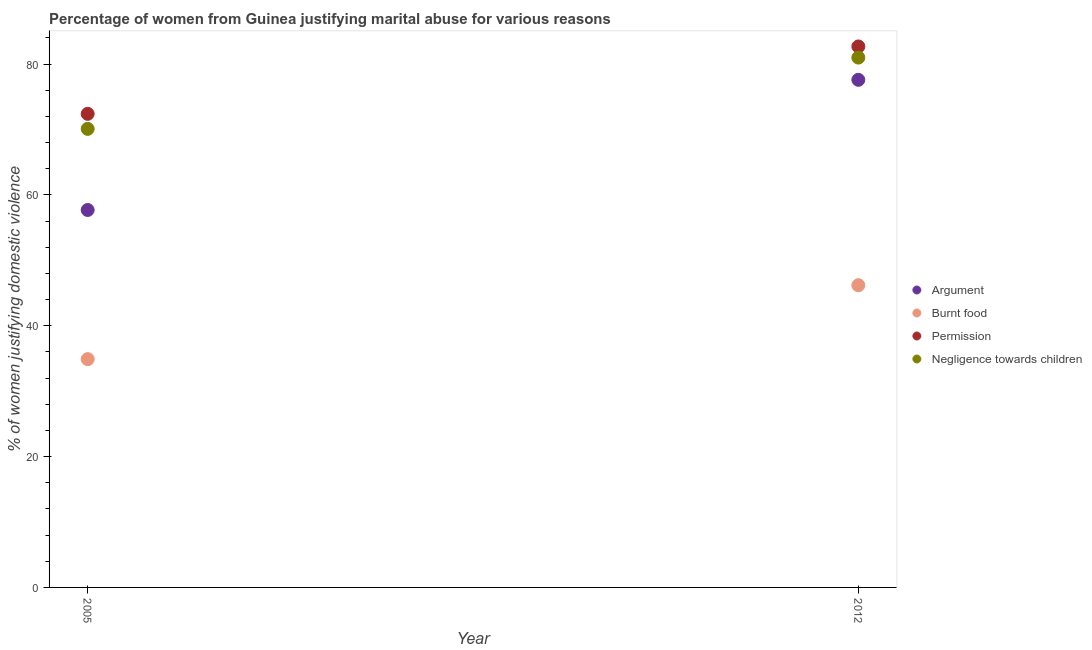How many different coloured dotlines are there?
Ensure brevity in your answer.  4. What is the percentage of women justifying abuse for showing negligence towards children in 2012?
Offer a terse response. 81. Across all years, what is the maximum percentage of women justifying abuse for going without permission?
Your answer should be compact. 82.7. Across all years, what is the minimum percentage of women justifying abuse for showing negligence towards children?
Keep it short and to the point. 70.1. What is the total percentage of women justifying abuse for showing negligence towards children in the graph?
Offer a terse response. 151.1. What is the difference between the percentage of women justifying abuse for showing negligence towards children in 2005 and that in 2012?
Keep it short and to the point. -10.9. What is the difference between the percentage of women justifying abuse for showing negligence towards children in 2012 and the percentage of women justifying abuse in the case of an argument in 2005?
Give a very brief answer. 23.3. What is the average percentage of women justifying abuse for showing negligence towards children per year?
Make the answer very short. 75.55. In the year 2012, what is the difference between the percentage of women justifying abuse for going without permission and percentage of women justifying abuse for burning food?
Provide a succinct answer. 36.5. In how many years, is the percentage of women justifying abuse in the case of an argument greater than 64 %?
Offer a terse response. 1. What is the ratio of the percentage of women justifying abuse for showing negligence towards children in 2005 to that in 2012?
Make the answer very short. 0.87. Is it the case that in every year, the sum of the percentage of women justifying abuse in the case of an argument and percentage of women justifying abuse for burning food is greater than the sum of percentage of women justifying abuse for going without permission and percentage of women justifying abuse for showing negligence towards children?
Keep it short and to the point. No. Is it the case that in every year, the sum of the percentage of women justifying abuse in the case of an argument and percentage of women justifying abuse for burning food is greater than the percentage of women justifying abuse for going without permission?
Your answer should be very brief. Yes. Does the percentage of women justifying abuse for burning food monotonically increase over the years?
Keep it short and to the point. Yes. Does the graph contain grids?
Offer a terse response. No. Where does the legend appear in the graph?
Ensure brevity in your answer.  Center right. How many legend labels are there?
Make the answer very short. 4. How are the legend labels stacked?
Make the answer very short. Vertical. What is the title of the graph?
Make the answer very short. Percentage of women from Guinea justifying marital abuse for various reasons. What is the label or title of the Y-axis?
Provide a short and direct response. % of women justifying domestic violence. What is the % of women justifying domestic violence of Argument in 2005?
Keep it short and to the point. 57.7. What is the % of women justifying domestic violence in Burnt food in 2005?
Offer a terse response. 34.9. What is the % of women justifying domestic violence of Permission in 2005?
Your answer should be compact. 72.4. What is the % of women justifying domestic violence in Negligence towards children in 2005?
Keep it short and to the point. 70.1. What is the % of women justifying domestic violence of Argument in 2012?
Your answer should be very brief. 77.6. What is the % of women justifying domestic violence in Burnt food in 2012?
Offer a very short reply. 46.2. What is the % of women justifying domestic violence in Permission in 2012?
Ensure brevity in your answer.  82.7. What is the % of women justifying domestic violence of Negligence towards children in 2012?
Your answer should be compact. 81. Across all years, what is the maximum % of women justifying domestic violence of Argument?
Provide a succinct answer. 77.6. Across all years, what is the maximum % of women justifying domestic violence of Burnt food?
Provide a short and direct response. 46.2. Across all years, what is the maximum % of women justifying domestic violence of Permission?
Your response must be concise. 82.7. Across all years, what is the minimum % of women justifying domestic violence of Argument?
Provide a short and direct response. 57.7. Across all years, what is the minimum % of women justifying domestic violence of Burnt food?
Provide a succinct answer. 34.9. Across all years, what is the minimum % of women justifying domestic violence in Permission?
Make the answer very short. 72.4. Across all years, what is the minimum % of women justifying domestic violence of Negligence towards children?
Offer a very short reply. 70.1. What is the total % of women justifying domestic violence of Argument in the graph?
Give a very brief answer. 135.3. What is the total % of women justifying domestic violence of Burnt food in the graph?
Your response must be concise. 81.1. What is the total % of women justifying domestic violence of Permission in the graph?
Provide a succinct answer. 155.1. What is the total % of women justifying domestic violence in Negligence towards children in the graph?
Provide a succinct answer. 151.1. What is the difference between the % of women justifying domestic violence of Argument in 2005 and that in 2012?
Provide a succinct answer. -19.9. What is the difference between the % of women justifying domestic violence of Burnt food in 2005 and that in 2012?
Offer a terse response. -11.3. What is the difference between the % of women justifying domestic violence of Permission in 2005 and that in 2012?
Ensure brevity in your answer.  -10.3. What is the difference between the % of women justifying domestic violence of Negligence towards children in 2005 and that in 2012?
Make the answer very short. -10.9. What is the difference between the % of women justifying domestic violence in Argument in 2005 and the % of women justifying domestic violence in Negligence towards children in 2012?
Your answer should be compact. -23.3. What is the difference between the % of women justifying domestic violence in Burnt food in 2005 and the % of women justifying domestic violence in Permission in 2012?
Provide a short and direct response. -47.8. What is the difference between the % of women justifying domestic violence in Burnt food in 2005 and the % of women justifying domestic violence in Negligence towards children in 2012?
Provide a succinct answer. -46.1. What is the average % of women justifying domestic violence in Argument per year?
Give a very brief answer. 67.65. What is the average % of women justifying domestic violence of Burnt food per year?
Offer a terse response. 40.55. What is the average % of women justifying domestic violence in Permission per year?
Offer a very short reply. 77.55. What is the average % of women justifying domestic violence of Negligence towards children per year?
Offer a very short reply. 75.55. In the year 2005, what is the difference between the % of women justifying domestic violence in Argument and % of women justifying domestic violence in Burnt food?
Keep it short and to the point. 22.8. In the year 2005, what is the difference between the % of women justifying domestic violence of Argument and % of women justifying domestic violence of Permission?
Offer a terse response. -14.7. In the year 2005, what is the difference between the % of women justifying domestic violence in Argument and % of women justifying domestic violence in Negligence towards children?
Make the answer very short. -12.4. In the year 2005, what is the difference between the % of women justifying domestic violence in Burnt food and % of women justifying domestic violence in Permission?
Your response must be concise. -37.5. In the year 2005, what is the difference between the % of women justifying domestic violence in Burnt food and % of women justifying domestic violence in Negligence towards children?
Offer a very short reply. -35.2. In the year 2005, what is the difference between the % of women justifying domestic violence in Permission and % of women justifying domestic violence in Negligence towards children?
Offer a terse response. 2.3. In the year 2012, what is the difference between the % of women justifying domestic violence of Argument and % of women justifying domestic violence of Burnt food?
Give a very brief answer. 31.4. In the year 2012, what is the difference between the % of women justifying domestic violence in Argument and % of women justifying domestic violence in Permission?
Provide a short and direct response. -5.1. In the year 2012, what is the difference between the % of women justifying domestic violence in Argument and % of women justifying domestic violence in Negligence towards children?
Keep it short and to the point. -3.4. In the year 2012, what is the difference between the % of women justifying domestic violence of Burnt food and % of women justifying domestic violence of Permission?
Your answer should be very brief. -36.5. In the year 2012, what is the difference between the % of women justifying domestic violence of Burnt food and % of women justifying domestic violence of Negligence towards children?
Your answer should be very brief. -34.8. In the year 2012, what is the difference between the % of women justifying domestic violence in Permission and % of women justifying domestic violence in Negligence towards children?
Your answer should be compact. 1.7. What is the ratio of the % of women justifying domestic violence in Argument in 2005 to that in 2012?
Your answer should be compact. 0.74. What is the ratio of the % of women justifying domestic violence of Burnt food in 2005 to that in 2012?
Offer a terse response. 0.76. What is the ratio of the % of women justifying domestic violence of Permission in 2005 to that in 2012?
Offer a terse response. 0.88. What is the ratio of the % of women justifying domestic violence of Negligence towards children in 2005 to that in 2012?
Make the answer very short. 0.87. What is the difference between the highest and the lowest % of women justifying domestic violence of Negligence towards children?
Provide a succinct answer. 10.9. 